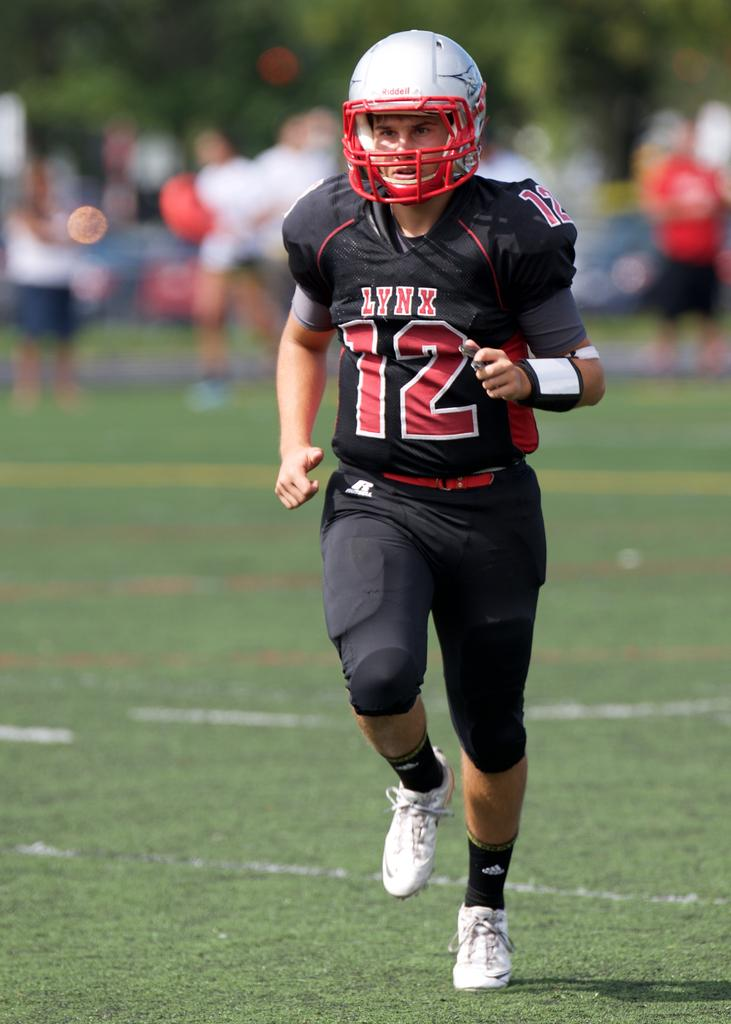Who is present in the image? There is a person in the image. What type of clothing is the person wearing? The person is wearing a sports jersey. What protective gear is the person wearing? The person is wearing a helmet. What type of surface is visible in the image? There is green grass visible in the image. How many girls are sitting on the egg in the image? There is no egg or girls present in the image. 